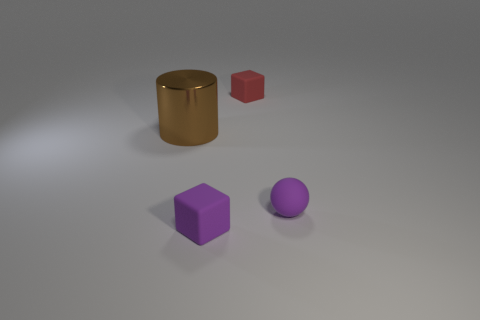Add 2 rubber objects. How many objects exist? 6 Subtract all spheres. How many objects are left? 3 Add 4 cylinders. How many cylinders are left? 5 Add 1 rubber blocks. How many rubber blocks exist? 3 Subtract 0 cyan cubes. How many objects are left? 4 Subtract all tiny matte objects. Subtract all big brown metal objects. How many objects are left? 0 